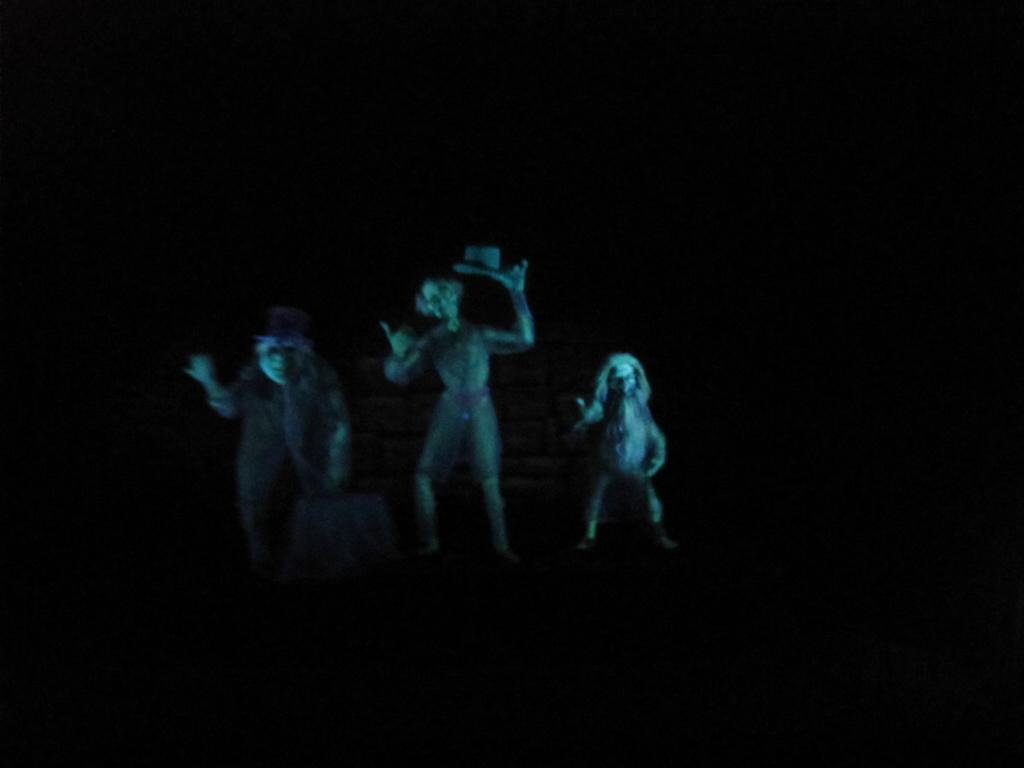Could you give a brief overview of what you see in this image? In this image we can see the statues of some persons who are standing in darkness and we can see some light falling on their face. 